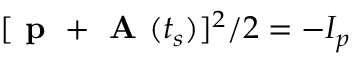Convert formula to latex. <formula><loc_0><loc_0><loc_500><loc_500>[ p + A ( t _ { s } ) ] ^ { 2 } / 2 = - I _ { p }</formula> 